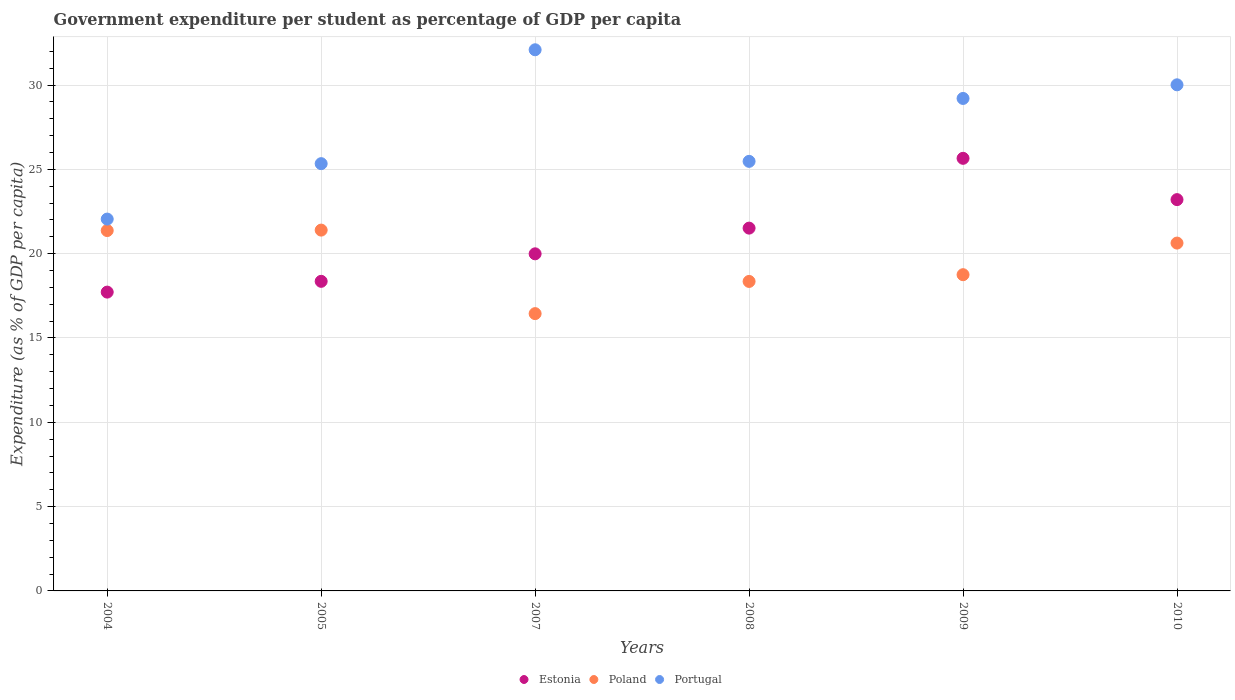What is the percentage of expenditure per student in Portugal in 2009?
Offer a very short reply. 29.2. Across all years, what is the maximum percentage of expenditure per student in Poland?
Keep it short and to the point. 21.4. Across all years, what is the minimum percentage of expenditure per student in Estonia?
Keep it short and to the point. 17.72. What is the total percentage of expenditure per student in Portugal in the graph?
Provide a succinct answer. 164.16. What is the difference between the percentage of expenditure per student in Estonia in 2004 and that in 2008?
Your answer should be compact. -3.79. What is the difference between the percentage of expenditure per student in Estonia in 2004 and the percentage of expenditure per student in Poland in 2005?
Your answer should be compact. -3.68. What is the average percentage of expenditure per student in Portugal per year?
Give a very brief answer. 27.36. In the year 2009, what is the difference between the percentage of expenditure per student in Poland and percentage of expenditure per student in Portugal?
Provide a short and direct response. -10.45. In how many years, is the percentage of expenditure per student in Poland greater than 31 %?
Your response must be concise. 0. What is the ratio of the percentage of expenditure per student in Portugal in 2004 to that in 2008?
Ensure brevity in your answer.  0.87. Is the difference between the percentage of expenditure per student in Poland in 2008 and 2009 greater than the difference between the percentage of expenditure per student in Portugal in 2008 and 2009?
Offer a terse response. Yes. What is the difference between the highest and the second highest percentage of expenditure per student in Poland?
Your answer should be compact. 0.03. What is the difference between the highest and the lowest percentage of expenditure per student in Poland?
Keep it short and to the point. 4.95. Is the percentage of expenditure per student in Estonia strictly less than the percentage of expenditure per student in Portugal over the years?
Your answer should be compact. Yes. How many dotlines are there?
Offer a very short reply. 3. How many years are there in the graph?
Make the answer very short. 6. Are the values on the major ticks of Y-axis written in scientific E-notation?
Your answer should be very brief. No. Does the graph contain grids?
Keep it short and to the point. Yes. How many legend labels are there?
Your answer should be very brief. 3. How are the legend labels stacked?
Make the answer very short. Horizontal. What is the title of the graph?
Ensure brevity in your answer.  Government expenditure per student as percentage of GDP per capita. What is the label or title of the X-axis?
Offer a very short reply. Years. What is the label or title of the Y-axis?
Ensure brevity in your answer.  Expenditure (as % of GDP per capita). What is the Expenditure (as % of GDP per capita) of Estonia in 2004?
Give a very brief answer. 17.72. What is the Expenditure (as % of GDP per capita) in Poland in 2004?
Provide a succinct answer. 21.37. What is the Expenditure (as % of GDP per capita) of Portugal in 2004?
Offer a terse response. 22.05. What is the Expenditure (as % of GDP per capita) in Estonia in 2005?
Keep it short and to the point. 18.36. What is the Expenditure (as % of GDP per capita) in Poland in 2005?
Offer a very short reply. 21.4. What is the Expenditure (as % of GDP per capita) of Portugal in 2005?
Ensure brevity in your answer.  25.34. What is the Expenditure (as % of GDP per capita) in Estonia in 2007?
Ensure brevity in your answer.  19.99. What is the Expenditure (as % of GDP per capita) of Poland in 2007?
Give a very brief answer. 16.44. What is the Expenditure (as % of GDP per capita) in Portugal in 2007?
Provide a short and direct response. 32.09. What is the Expenditure (as % of GDP per capita) in Estonia in 2008?
Give a very brief answer. 21.51. What is the Expenditure (as % of GDP per capita) in Poland in 2008?
Offer a very short reply. 18.35. What is the Expenditure (as % of GDP per capita) of Portugal in 2008?
Provide a short and direct response. 25.47. What is the Expenditure (as % of GDP per capita) in Estonia in 2009?
Your answer should be compact. 25.65. What is the Expenditure (as % of GDP per capita) of Poland in 2009?
Make the answer very short. 18.75. What is the Expenditure (as % of GDP per capita) of Portugal in 2009?
Your answer should be compact. 29.2. What is the Expenditure (as % of GDP per capita) of Estonia in 2010?
Provide a short and direct response. 23.2. What is the Expenditure (as % of GDP per capita) of Poland in 2010?
Offer a very short reply. 20.63. What is the Expenditure (as % of GDP per capita) of Portugal in 2010?
Ensure brevity in your answer.  30.01. Across all years, what is the maximum Expenditure (as % of GDP per capita) of Estonia?
Give a very brief answer. 25.65. Across all years, what is the maximum Expenditure (as % of GDP per capita) in Poland?
Your answer should be very brief. 21.4. Across all years, what is the maximum Expenditure (as % of GDP per capita) in Portugal?
Provide a short and direct response. 32.09. Across all years, what is the minimum Expenditure (as % of GDP per capita) in Estonia?
Your answer should be compact. 17.72. Across all years, what is the minimum Expenditure (as % of GDP per capita) of Poland?
Your answer should be compact. 16.44. Across all years, what is the minimum Expenditure (as % of GDP per capita) in Portugal?
Provide a succinct answer. 22.05. What is the total Expenditure (as % of GDP per capita) of Estonia in the graph?
Make the answer very short. 126.44. What is the total Expenditure (as % of GDP per capita) in Poland in the graph?
Your response must be concise. 116.94. What is the total Expenditure (as % of GDP per capita) in Portugal in the graph?
Offer a terse response. 164.16. What is the difference between the Expenditure (as % of GDP per capita) in Estonia in 2004 and that in 2005?
Provide a succinct answer. -0.64. What is the difference between the Expenditure (as % of GDP per capita) of Poland in 2004 and that in 2005?
Offer a very short reply. -0.03. What is the difference between the Expenditure (as % of GDP per capita) in Portugal in 2004 and that in 2005?
Offer a terse response. -3.29. What is the difference between the Expenditure (as % of GDP per capita) of Estonia in 2004 and that in 2007?
Provide a succinct answer. -2.27. What is the difference between the Expenditure (as % of GDP per capita) in Poland in 2004 and that in 2007?
Make the answer very short. 4.93. What is the difference between the Expenditure (as % of GDP per capita) of Portugal in 2004 and that in 2007?
Make the answer very short. -10.04. What is the difference between the Expenditure (as % of GDP per capita) of Estonia in 2004 and that in 2008?
Offer a very short reply. -3.79. What is the difference between the Expenditure (as % of GDP per capita) in Poland in 2004 and that in 2008?
Provide a succinct answer. 3.02. What is the difference between the Expenditure (as % of GDP per capita) of Portugal in 2004 and that in 2008?
Offer a terse response. -3.42. What is the difference between the Expenditure (as % of GDP per capita) of Estonia in 2004 and that in 2009?
Your answer should be compact. -7.93. What is the difference between the Expenditure (as % of GDP per capita) in Poland in 2004 and that in 2009?
Offer a terse response. 2.62. What is the difference between the Expenditure (as % of GDP per capita) of Portugal in 2004 and that in 2009?
Provide a succinct answer. -7.15. What is the difference between the Expenditure (as % of GDP per capita) in Estonia in 2004 and that in 2010?
Your answer should be very brief. -5.48. What is the difference between the Expenditure (as % of GDP per capita) of Poland in 2004 and that in 2010?
Give a very brief answer. 0.74. What is the difference between the Expenditure (as % of GDP per capita) in Portugal in 2004 and that in 2010?
Give a very brief answer. -7.96. What is the difference between the Expenditure (as % of GDP per capita) of Estonia in 2005 and that in 2007?
Offer a very short reply. -1.63. What is the difference between the Expenditure (as % of GDP per capita) of Poland in 2005 and that in 2007?
Your answer should be compact. 4.95. What is the difference between the Expenditure (as % of GDP per capita) of Portugal in 2005 and that in 2007?
Keep it short and to the point. -6.75. What is the difference between the Expenditure (as % of GDP per capita) of Estonia in 2005 and that in 2008?
Provide a short and direct response. -3.16. What is the difference between the Expenditure (as % of GDP per capita) in Poland in 2005 and that in 2008?
Offer a terse response. 3.04. What is the difference between the Expenditure (as % of GDP per capita) in Portugal in 2005 and that in 2008?
Your answer should be compact. -0.14. What is the difference between the Expenditure (as % of GDP per capita) in Estonia in 2005 and that in 2009?
Make the answer very short. -7.29. What is the difference between the Expenditure (as % of GDP per capita) of Poland in 2005 and that in 2009?
Provide a short and direct response. 2.64. What is the difference between the Expenditure (as % of GDP per capita) in Portugal in 2005 and that in 2009?
Keep it short and to the point. -3.87. What is the difference between the Expenditure (as % of GDP per capita) of Estonia in 2005 and that in 2010?
Give a very brief answer. -4.85. What is the difference between the Expenditure (as % of GDP per capita) of Poland in 2005 and that in 2010?
Offer a terse response. 0.77. What is the difference between the Expenditure (as % of GDP per capita) of Portugal in 2005 and that in 2010?
Your response must be concise. -4.67. What is the difference between the Expenditure (as % of GDP per capita) of Estonia in 2007 and that in 2008?
Provide a short and direct response. -1.52. What is the difference between the Expenditure (as % of GDP per capita) of Poland in 2007 and that in 2008?
Ensure brevity in your answer.  -1.91. What is the difference between the Expenditure (as % of GDP per capita) of Portugal in 2007 and that in 2008?
Your answer should be compact. 6.62. What is the difference between the Expenditure (as % of GDP per capita) in Estonia in 2007 and that in 2009?
Ensure brevity in your answer.  -5.66. What is the difference between the Expenditure (as % of GDP per capita) in Poland in 2007 and that in 2009?
Give a very brief answer. -2.31. What is the difference between the Expenditure (as % of GDP per capita) in Portugal in 2007 and that in 2009?
Ensure brevity in your answer.  2.89. What is the difference between the Expenditure (as % of GDP per capita) of Estonia in 2007 and that in 2010?
Provide a succinct answer. -3.21. What is the difference between the Expenditure (as % of GDP per capita) in Poland in 2007 and that in 2010?
Your response must be concise. -4.18. What is the difference between the Expenditure (as % of GDP per capita) in Portugal in 2007 and that in 2010?
Provide a short and direct response. 2.08. What is the difference between the Expenditure (as % of GDP per capita) in Estonia in 2008 and that in 2009?
Make the answer very short. -4.14. What is the difference between the Expenditure (as % of GDP per capita) of Poland in 2008 and that in 2009?
Give a very brief answer. -0.4. What is the difference between the Expenditure (as % of GDP per capita) in Portugal in 2008 and that in 2009?
Provide a succinct answer. -3.73. What is the difference between the Expenditure (as % of GDP per capita) of Estonia in 2008 and that in 2010?
Give a very brief answer. -1.69. What is the difference between the Expenditure (as % of GDP per capita) in Poland in 2008 and that in 2010?
Offer a terse response. -2.27. What is the difference between the Expenditure (as % of GDP per capita) of Portugal in 2008 and that in 2010?
Offer a terse response. -4.54. What is the difference between the Expenditure (as % of GDP per capita) in Estonia in 2009 and that in 2010?
Make the answer very short. 2.45. What is the difference between the Expenditure (as % of GDP per capita) in Poland in 2009 and that in 2010?
Make the answer very short. -1.87. What is the difference between the Expenditure (as % of GDP per capita) of Portugal in 2009 and that in 2010?
Provide a short and direct response. -0.81. What is the difference between the Expenditure (as % of GDP per capita) in Estonia in 2004 and the Expenditure (as % of GDP per capita) in Poland in 2005?
Provide a succinct answer. -3.68. What is the difference between the Expenditure (as % of GDP per capita) of Estonia in 2004 and the Expenditure (as % of GDP per capita) of Portugal in 2005?
Offer a terse response. -7.62. What is the difference between the Expenditure (as % of GDP per capita) in Poland in 2004 and the Expenditure (as % of GDP per capita) in Portugal in 2005?
Ensure brevity in your answer.  -3.97. What is the difference between the Expenditure (as % of GDP per capita) of Estonia in 2004 and the Expenditure (as % of GDP per capita) of Poland in 2007?
Your response must be concise. 1.28. What is the difference between the Expenditure (as % of GDP per capita) in Estonia in 2004 and the Expenditure (as % of GDP per capita) in Portugal in 2007?
Provide a succinct answer. -14.37. What is the difference between the Expenditure (as % of GDP per capita) in Poland in 2004 and the Expenditure (as % of GDP per capita) in Portugal in 2007?
Your answer should be very brief. -10.72. What is the difference between the Expenditure (as % of GDP per capita) of Estonia in 2004 and the Expenditure (as % of GDP per capita) of Poland in 2008?
Offer a very short reply. -0.63. What is the difference between the Expenditure (as % of GDP per capita) of Estonia in 2004 and the Expenditure (as % of GDP per capita) of Portugal in 2008?
Make the answer very short. -7.75. What is the difference between the Expenditure (as % of GDP per capita) in Poland in 2004 and the Expenditure (as % of GDP per capita) in Portugal in 2008?
Your response must be concise. -4.1. What is the difference between the Expenditure (as % of GDP per capita) in Estonia in 2004 and the Expenditure (as % of GDP per capita) in Poland in 2009?
Make the answer very short. -1.03. What is the difference between the Expenditure (as % of GDP per capita) in Estonia in 2004 and the Expenditure (as % of GDP per capita) in Portugal in 2009?
Offer a very short reply. -11.48. What is the difference between the Expenditure (as % of GDP per capita) of Poland in 2004 and the Expenditure (as % of GDP per capita) of Portugal in 2009?
Keep it short and to the point. -7.83. What is the difference between the Expenditure (as % of GDP per capita) of Estonia in 2004 and the Expenditure (as % of GDP per capita) of Poland in 2010?
Offer a very short reply. -2.91. What is the difference between the Expenditure (as % of GDP per capita) of Estonia in 2004 and the Expenditure (as % of GDP per capita) of Portugal in 2010?
Provide a short and direct response. -12.29. What is the difference between the Expenditure (as % of GDP per capita) in Poland in 2004 and the Expenditure (as % of GDP per capita) in Portugal in 2010?
Ensure brevity in your answer.  -8.64. What is the difference between the Expenditure (as % of GDP per capita) of Estonia in 2005 and the Expenditure (as % of GDP per capita) of Poland in 2007?
Ensure brevity in your answer.  1.92. What is the difference between the Expenditure (as % of GDP per capita) in Estonia in 2005 and the Expenditure (as % of GDP per capita) in Portugal in 2007?
Your answer should be very brief. -13.73. What is the difference between the Expenditure (as % of GDP per capita) in Poland in 2005 and the Expenditure (as % of GDP per capita) in Portugal in 2007?
Provide a short and direct response. -10.69. What is the difference between the Expenditure (as % of GDP per capita) in Estonia in 2005 and the Expenditure (as % of GDP per capita) in Poland in 2008?
Provide a succinct answer. 0.01. What is the difference between the Expenditure (as % of GDP per capita) in Estonia in 2005 and the Expenditure (as % of GDP per capita) in Portugal in 2008?
Offer a terse response. -7.11. What is the difference between the Expenditure (as % of GDP per capita) in Poland in 2005 and the Expenditure (as % of GDP per capita) in Portugal in 2008?
Give a very brief answer. -4.08. What is the difference between the Expenditure (as % of GDP per capita) of Estonia in 2005 and the Expenditure (as % of GDP per capita) of Poland in 2009?
Provide a short and direct response. -0.39. What is the difference between the Expenditure (as % of GDP per capita) of Estonia in 2005 and the Expenditure (as % of GDP per capita) of Portugal in 2009?
Your answer should be compact. -10.84. What is the difference between the Expenditure (as % of GDP per capita) of Poland in 2005 and the Expenditure (as % of GDP per capita) of Portugal in 2009?
Provide a short and direct response. -7.81. What is the difference between the Expenditure (as % of GDP per capita) of Estonia in 2005 and the Expenditure (as % of GDP per capita) of Poland in 2010?
Give a very brief answer. -2.27. What is the difference between the Expenditure (as % of GDP per capita) in Estonia in 2005 and the Expenditure (as % of GDP per capita) in Portugal in 2010?
Your answer should be compact. -11.65. What is the difference between the Expenditure (as % of GDP per capita) of Poland in 2005 and the Expenditure (as % of GDP per capita) of Portugal in 2010?
Make the answer very short. -8.62. What is the difference between the Expenditure (as % of GDP per capita) in Estonia in 2007 and the Expenditure (as % of GDP per capita) in Poland in 2008?
Your answer should be very brief. 1.64. What is the difference between the Expenditure (as % of GDP per capita) in Estonia in 2007 and the Expenditure (as % of GDP per capita) in Portugal in 2008?
Your answer should be very brief. -5.48. What is the difference between the Expenditure (as % of GDP per capita) in Poland in 2007 and the Expenditure (as % of GDP per capita) in Portugal in 2008?
Your response must be concise. -9.03. What is the difference between the Expenditure (as % of GDP per capita) of Estonia in 2007 and the Expenditure (as % of GDP per capita) of Poland in 2009?
Provide a short and direct response. 1.24. What is the difference between the Expenditure (as % of GDP per capita) of Estonia in 2007 and the Expenditure (as % of GDP per capita) of Portugal in 2009?
Make the answer very short. -9.21. What is the difference between the Expenditure (as % of GDP per capita) of Poland in 2007 and the Expenditure (as % of GDP per capita) of Portugal in 2009?
Your answer should be compact. -12.76. What is the difference between the Expenditure (as % of GDP per capita) of Estonia in 2007 and the Expenditure (as % of GDP per capita) of Poland in 2010?
Offer a terse response. -0.64. What is the difference between the Expenditure (as % of GDP per capita) in Estonia in 2007 and the Expenditure (as % of GDP per capita) in Portugal in 2010?
Make the answer very short. -10.02. What is the difference between the Expenditure (as % of GDP per capita) of Poland in 2007 and the Expenditure (as % of GDP per capita) of Portugal in 2010?
Provide a succinct answer. -13.57. What is the difference between the Expenditure (as % of GDP per capita) in Estonia in 2008 and the Expenditure (as % of GDP per capita) in Poland in 2009?
Make the answer very short. 2.76. What is the difference between the Expenditure (as % of GDP per capita) in Estonia in 2008 and the Expenditure (as % of GDP per capita) in Portugal in 2009?
Ensure brevity in your answer.  -7.69. What is the difference between the Expenditure (as % of GDP per capita) of Poland in 2008 and the Expenditure (as % of GDP per capita) of Portugal in 2009?
Your response must be concise. -10.85. What is the difference between the Expenditure (as % of GDP per capita) of Estonia in 2008 and the Expenditure (as % of GDP per capita) of Poland in 2010?
Offer a very short reply. 0.89. What is the difference between the Expenditure (as % of GDP per capita) of Estonia in 2008 and the Expenditure (as % of GDP per capita) of Portugal in 2010?
Provide a succinct answer. -8.5. What is the difference between the Expenditure (as % of GDP per capita) in Poland in 2008 and the Expenditure (as % of GDP per capita) in Portugal in 2010?
Offer a very short reply. -11.66. What is the difference between the Expenditure (as % of GDP per capita) of Estonia in 2009 and the Expenditure (as % of GDP per capita) of Poland in 2010?
Give a very brief answer. 5.03. What is the difference between the Expenditure (as % of GDP per capita) of Estonia in 2009 and the Expenditure (as % of GDP per capita) of Portugal in 2010?
Offer a terse response. -4.36. What is the difference between the Expenditure (as % of GDP per capita) of Poland in 2009 and the Expenditure (as % of GDP per capita) of Portugal in 2010?
Your response must be concise. -11.26. What is the average Expenditure (as % of GDP per capita) in Estonia per year?
Your answer should be very brief. 21.07. What is the average Expenditure (as % of GDP per capita) in Poland per year?
Keep it short and to the point. 19.49. What is the average Expenditure (as % of GDP per capita) in Portugal per year?
Offer a terse response. 27.36. In the year 2004, what is the difference between the Expenditure (as % of GDP per capita) in Estonia and Expenditure (as % of GDP per capita) in Poland?
Your answer should be very brief. -3.65. In the year 2004, what is the difference between the Expenditure (as % of GDP per capita) in Estonia and Expenditure (as % of GDP per capita) in Portugal?
Give a very brief answer. -4.33. In the year 2004, what is the difference between the Expenditure (as % of GDP per capita) in Poland and Expenditure (as % of GDP per capita) in Portugal?
Offer a terse response. -0.68. In the year 2005, what is the difference between the Expenditure (as % of GDP per capita) of Estonia and Expenditure (as % of GDP per capita) of Poland?
Provide a short and direct response. -3.04. In the year 2005, what is the difference between the Expenditure (as % of GDP per capita) of Estonia and Expenditure (as % of GDP per capita) of Portugal?
Ensure brevity in your answer.  -6.98. In the year 2005, what is the difference between the Expenditure (as % of GDP per capita) of Poland and Expenditure (as % of GDP per capita) of Portugal?
Offer a terse response. -3.94. In the year 2007, what is the difference between the Expenditure (as % of GDP per capita) of Estonia and Expenditure (as % of GDP per capita) of Poland?
Your answer should be very brief. 3.55. In the year 2007, what is the difference between the Expenditure (as % of GDP per capita) of Estonia and Expenditure (as % of GDP per capita) of Portugal?
Ensure brevity in your answer.  -12.1. In the year 2007, what is the difference between the Expenditure (as % of GDP per capita) of Poland and Expenditure (as % of GDP per capita) of Portugal?
Your response must be concise. -15.65. In the year 2008, what is the difference between the Expenditure (as % of GDP per capita) in Estonia and Expenditure (as % of GDP per capita) in Poland?
Ensure brevity in your answer.  3.16. In the year 2008, what is the difference between the Expenditure (as % of GDP per capita) in Estonia and Expenditure (as % of GDP per capita) in Portugal?
Make the answer very short. -3.96. In the year 2008, what is the difference between the Expenditure (as % of GDP per capita) of Poland and Expenditure (as % of GDP per capita) of Portugal?
Make the answer very short. -7.12. In the year 2009, what is the difference between the Expenditure (as % of GDP per capita) of Estonia and Expenditure (as % of GDP per capita) of Poland?
Give a very brief answer. 6.9. In the year 2009, what is the difference between the Expenditure (as % of GDP per capita) in Estonia and Expenditure (as % of GDP per capita) in Portugal?
Keep it short and to the point. -3.55. In the year 2009, what is the difference between the Expenditure (as % of GDP per capita) of Poland and Expenditure (as % of GDP per capita) of Portugal?
Ensure brevity in your answer.  -10.45. In the year 2010, what is the difference between the Expenditure (as % of GDP per capita) in Estonia and Expenditure (as % of GDP per capita) in Poland?
Your answer should be compact. 2.58. In the year 2010, what is the difference between the Expenditure (as % of GDP per capita) in Estonia and Expenditure (as % of GDP per capita) in Portugal?
Keep it short and to the point. -6.81. In the year 2010, what is the difference between the Expenditure (as % of GDP per capita) in Poland and Expenditure (as % of GDP per capita) in Portugal?
Your answer should be compact. -9.38. What is the ratio of the Expenditure (as % of GDP per capita) of Estonia in 2004 to that in 2005?
Provide a succinct answer. 0.97. What is the ratio of the Expenditure (as % of GDP per capita) of Poland in 2004 to that in 2005?
Keep it short and to the point. 1. What is the ratio of the Expenditure (as % of GDP per capita) in Portugal in 2004 to that in 2005?
Your answer should be very brief. 0.87. What is the ratio of the Expenditure (as % of GDP per capita) of Estonia in 2004 to that in 2007?
Your answer should be very brief. 0.89. What is the ratio of the Expenditure (as % of GDP per capita) of Poland in 2004 to that in 2007?
Give a very brief answer. 1.3. What is the ratio of the Expenditure (as % of GDP per capita) in Portugal in 2004 to that in 2007?
Keep it short and to the point. 0.69. What is the ratio of the Expenditure (as % of GDP per capita) of Estonia in 2004 to that in 2008?
Offer a terse response. 0.82. What is the ratio of the Expenditure (as % of GDP per capita) in Poland in 2004 to that in 2008?
Make the answer very short. 1.16. What is the ratio of the Expenditure (as % of GDP per capita) of Portugal in 2004 to that in 2008?
Make the answer very short. 0.87. What is the ratio of the Expenditure (as % of GDP per capita) in Estonia in 2004 to that in 2009?
Ensure brevity in your answer.  0.69. What is the ratio of the Expenditure (as % of GDP per capita) in Poland in 2004 to that in 2009?
Make the answer very short. 1.14. What is the ratio of the Expenditure (as % of GDP per capita) of Portugal in 2004 to that in 2009?
Make the answer very short. 0.76. What is the ratio of the Expenditure (as % of GDP per capita) in Estonia in 2004 to that in 2010?
Provide a succinct answer. 0.76. What is the ratio of the Expenditure (as % of GDP per capita) of Poland in 2004 to that in 2010?
Your answer should be compact. 1.04. What is the ratio of the Expenditure (as % of GDP per capita) of Portugal in 2004 to that in 2010?
Make the answer very short. 0.73. What is the ratio of the Expenditure (as % of GDP per capita) in Estonia in 2005 to that in 2007?
Give a very brief answer. 0.92. What is the ratio of the Expenditure (as % of GDP per capita) of Poland in 2005 to that in 2007?
Your answer should be very brief. 1.3. What is the ratio of the Expenditure (as % of GDP per capita) in Portugal in 2005 to that in 2007?
Keep it short and to the point. 0.79. What is the ratio of the Expenditure (as % of GDP per capita) of Estonia in 2005 to that in 2008?
Offer a very short reply. 0.85. What is the ratio of the Expenditure (as % of GDP per capita) of Poland in 2005 to that in 2008?
Your answer should be compact. 1.17. What is the ratio of the Expenditure (as % of GDP per capita) of Portugal in 2005 to that in 2008?
Your response must be concise. 0.99. What is the ratio of the Expenditure (as % of GDP per capita) of Estonia in 2005 to that in 2009?
Keep it short and to the point. 0.72. What is the ratio of the Expenditure (as % of GDP per capita) of Poland in 2005 to that in 2009?
Your response must be concise. 1.14. What is the ratio of the Expenditure (as % of GDP per capita) in Portugal in 2005 to that in 2009?
Offer a very short reply. 0.87. What is the ratio of the Expenditure (as % of GDP per capita) in Estonia in 2005 to that in 2010?
Ensure brevity in your answer.  0.79. What is the ratio of the Expenditure (as % of GDP per capita) in Poland in 2005 to that in 2010?
Your answer should be compact. 1.04. What is the ratio of the Expenditure (as % of GDP per capita) in Portugal in 2005 to that in 2010?
Make the answer very short. 0.84. What is the ratio of the Expenditure (as % of GDP per capita) of Estonia in 2007 to that in 2008?
Your response must be concise. 0.93. What is the ratio of the Expenditure (as % of GDP per capita) in Poland in 2007 to that in 2008?
Provide a succinct answer. 0.9. What is the ratio of the Expenditure (as % of GDP per capita) in Portugal in 2007 to that in 2008?
Keep it short and to the point. 1.26. What is the ratio of the Expenditure (as % of GDP per capita) of Estonia in 2007 to that in 2009?
Make the answer very short. 0.78. What is the ratio of the Expenditure (as % of GDP per capita) in Poland in 2007 to that in 2009?
Provide a succinct answer. 0.88. What is the ratio of the Expenditure (as % of GDP per capita) of Portugal in 2007 to that in 2009?
Keep it short and to the point. 1.1. What is the ratio of the Expenditure (as % of GDP per capita) of Estonia in 2007 to that in 2010?
Your response must be concise. 0.86. What is the ratio of the Expenditure (as % of GDP per capita) of Poland in 2007 to that in 2010?
Your answer should be compact. 0.8. What is the ratio of the Expenditure (as % of GDP per capita) of Portugal in 2007 to that in 2010?
Ensure brevity in your answer.  1.07. What is the ratio of the Expenditure (as % of GDP per capita) of Estonia in 2008 to that in 2009?
Provide a succinct answer. 0.84. What is the ratio of the Expenditure (as % of GDP per capita) in Poland in 2008 to that in 2009?
Offer a very short reply. 0.98. What is the ratio of the Expenditure (as % of GDP per capita) of Portugal in 2008 to that in 2009?
Keep it short and to the point. 0.87. What is the ratio of the Expenditure (as % of GDP per capita) in Estonia in 2008 to that in 2010?
Your answer should be very brief. 0.93. What is the ratio of the Expenditure (as % of GDP per capita) in Poland in 2008 to that in 2010?
Ensure brevity in your answer.  0.89. What is the ratio of the Expenditure (as % of GDP per capita) in Portugal in 2008 to that in 2010?
Make the answer very short. 0.85. What is the ratio of the Expenditure (as % of GDP per capita) of Estonia in 2009 to that in 2010?
Offer a terse response. 1.11. What is the ratio of the Expenditure (as % of GDP per capita) in Poland in 2009 to that in 2010?
Ensure brevity in your answer.  0.91. What is the ratio of the Expenditure (as % of GDP per capita) in Portugal in 2009 to that in 2010?
Offer a very short reply. 0.97. What is the difference between the highest and the second highest Expenditure (as % of GDP per capita) of Estonia?
Make the answer very short. 2.45. What is the difference between the highest and the second highest Expenditure (as % of GDP per capita) in Poland?
Give a very brief answer. 0.03. What is the difference between the highest and the second highest Expenditure (as % of GDP per capita) of Portugal?
Provide a short and direct response. 2.08. What is the difference between the highest and the lowest Expenditure (as % of GDP per capita) in Estonia?
Keep it short and to the point. 7.93. What is the difference between the highest and the lowest Expenditure (as % of GDP per capita) in Poland?
Your answer should be very brief. 4.95. What is the difference between the highest and the lowest Expenditure (as % of GDP per capita) of Portugal?
Make the answer very short. 10.04. 